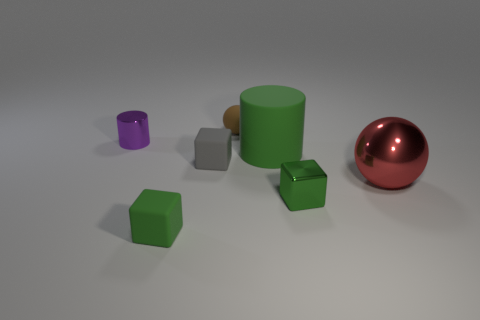Add 1 yellow cubes. How many objects exist? 8 Subtract all balls. How many objects are left? 5 Subtract 0 brown cylinders. How many objects are left? 7 Subtract all tiny purple rubber cubes. Subtract all tiny cylinders. How many objects are left? 6 Add 6 big matte cylinders. How many big matte cylinders are left? 7 Add 5 small metallic things. How many small metallic things exist? 7 